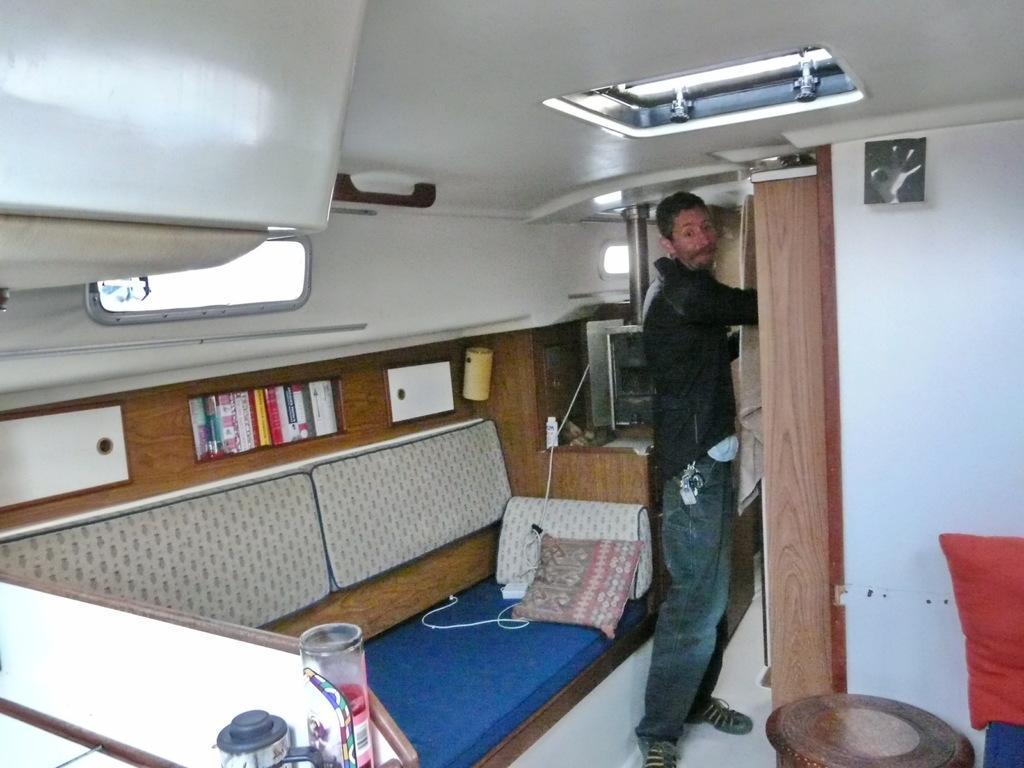In one or two sentences, can you explain what this image depicts? This is an inside view. On the left side there is a couch is placed on the floor. On the couch there are two pillows. In front of the couch there is a man standing. On the right side there is a table, wall and a pillow. It seems like an inside view of a vehicle. In the background there is a table on which there are some objects. 